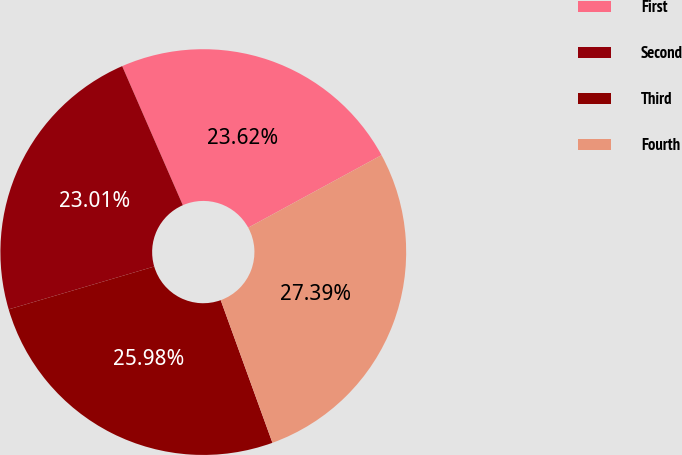Convert chart to OTSL. <chart><loc_0><loc_0><loc_500><loc_500><pie_chart><fcel>First<fcel>Second<fcel>Third<fcel>Fourth<nl><fcel>23.62%<fcel>23.01%<fcel>25.98%<fcel>27.39%<nl></chart> 